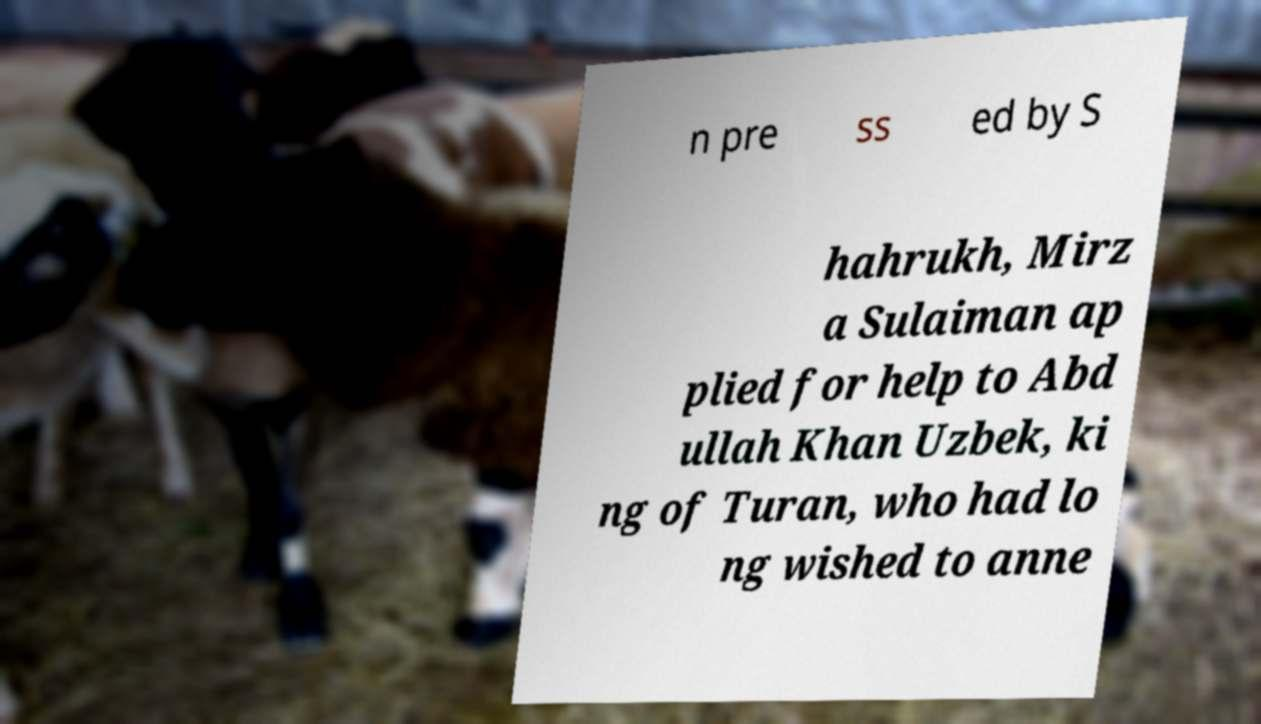Please read and relay the text visible in this image. What does it say? n pre ss ed by S hahrukh, Mirz a Sulaiman ap plied for help to Abd ullah Khan Uzbek, ki ng of Turan, who had lo ng wished to anne 